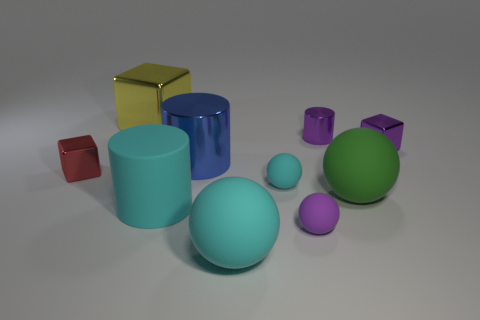Subtract all purple balls. How many balls are left? 3 Subtract all green balls. How many balls are left? 3 Subtract all cylinders. How many objects are left? 7 Add 2 big green spheres. How many big green spheres are left? 3 Add 3 tiny metallic blocks. How many tiny metallic blocks exist? 5 Subtract 1 cyan cylinders. How many objects are left? 9 Subtract 3 blocks. How many blocks are left? 0 Subtract all red spheres. Subtract all green cylinders. How many spheres are left? 4 Subtract all brown spheres. How many green cylinders are left? 0 Subtract all purple matte things. Subtract all big matte things. How many objects are left? 6 